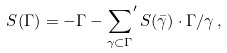<formula> <loc_0><loc_0><loc_500><loc_500>S ( \Gamma ) = - \Gamma - { \sum _ { \gamma \subset \Gamma } } ^ { \prime } \, S ( \bar { \gamma } ) \cdot \Gamma / \gamma \, ,</formula> 